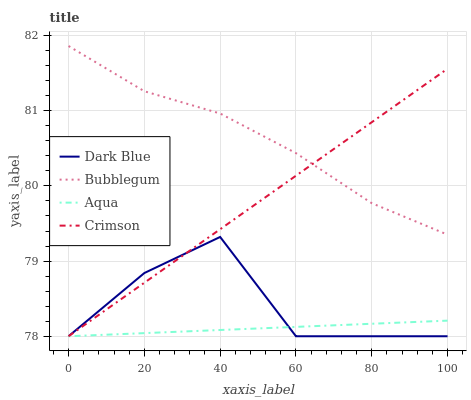Does Dark Blue have the minimum area under the curve?
Answer yes or no. No. Does Dark Blue have the maximum area under the curve?
Answer yes or no. No. Is Dark Blue the smoothest?
Answer yes or no. No. Is Aqua the roughest?
Answer yes or no. No. Does Bubblegum have the lowest value?
Answer yes or no. No. Does Dark Blue have the highest value?
Answer yes or no. No. Is Dark Blue less than Bubblegum?
Answer yes or no. Yes. Is Bubblegum greater than Aqua?
Answer yes or no. Yes. Does Dark Blue intersect Bubblegum?
Answer yes or no. No. 